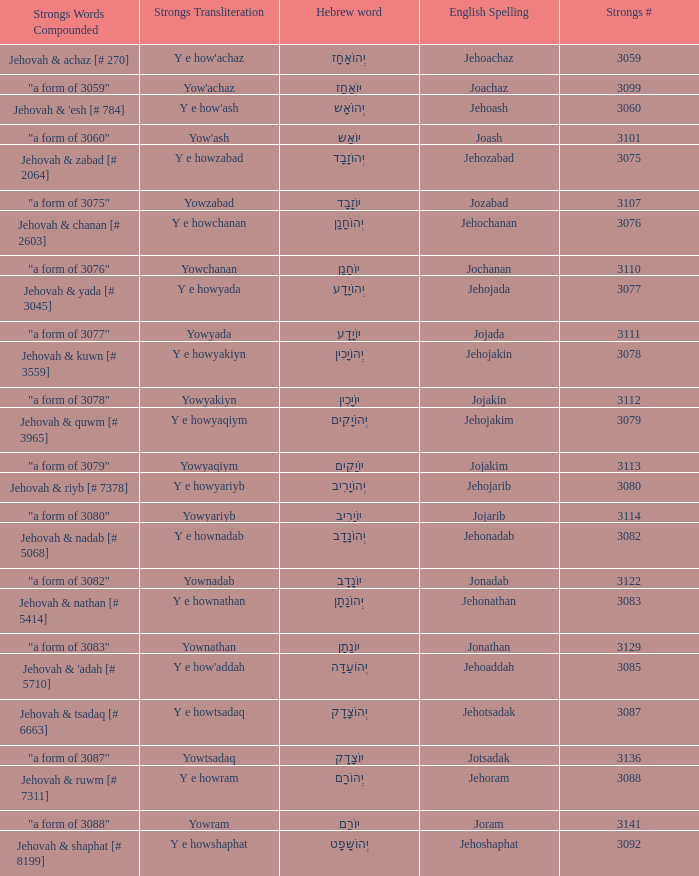What is the english spelling of the word that has the strongs trasliteration of y e howram? Jehoram. 